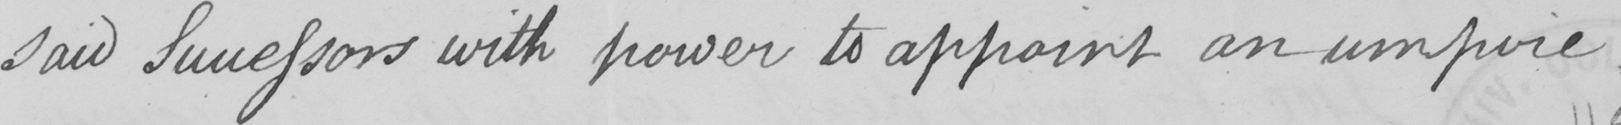What is written in this line of handwriting? said Successors with power to appoint an umpire .  _ 